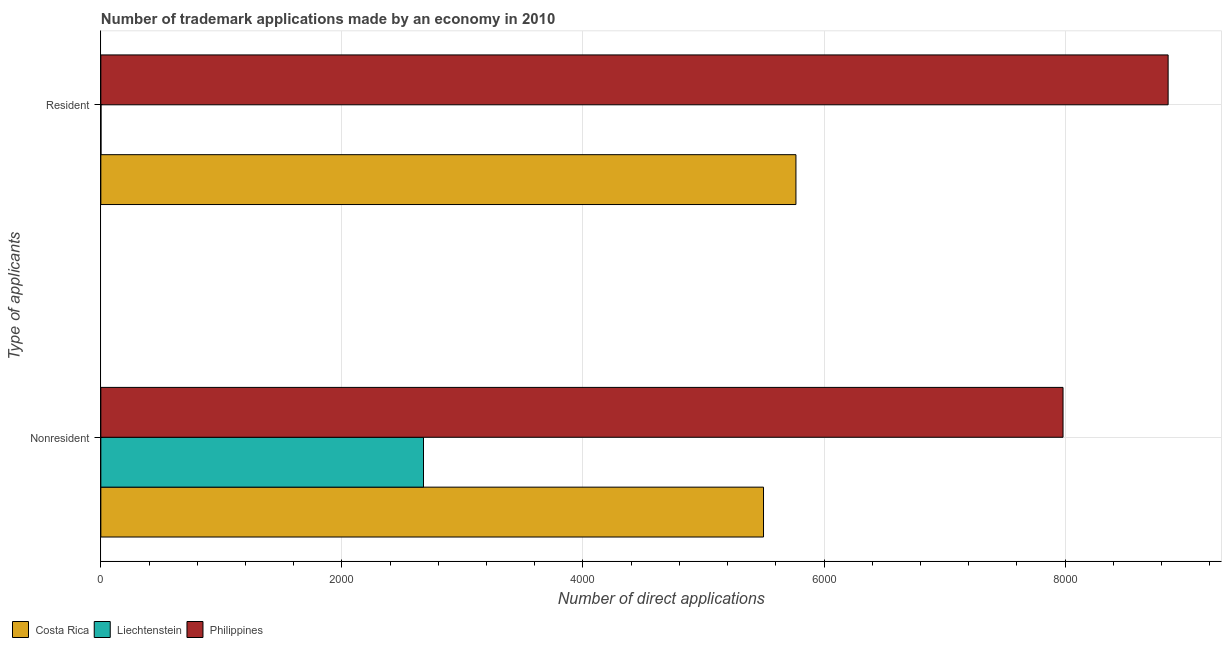How many different coloured bars are there?
Make the answer very short. 3. How many bars are there on the 2nd tick from the top?
Offer a very short reply. 3. What is the label of the 1st group of bars from the top?
Give a very brief answer. Resident. What is the number of trademark applications made by residents in Liechtenstein?
Your answer should be compact. 1. Across all countries, what is the maximum number of trademark applications made by residents?
Provide a succinct answer. 8855. Across all countries, what is the minimum number of trademark applications made by non residents?
Offer a terse response. 2677. In which country was the number of trademark applications made by non residents minimum?
Your answer should be very brief. Liechtenstein. What is the total number of trademark applications made by non residents in the graph?
Offer a terse response. 1.62e+04. What is the difference between the number of trademark applications made by non residents in Philippines and that in Costa Rica?
Your response must be concise. 2485. What is the difference between the number of trademark applications made by residents in Philippines and the number of trademark applications made by non residents in Liechtenstein?
Provide a short and direct response. 6178. What is the average number of trademark applications made by residents per country?
Your answer should be very brief. 4874.33. What is the difference between the number of trademark applications made by non residents and number of trademark applications made by residents in Costa Rica?
Your response must be concise. -269. What is the ratio of the number of trademark applications made by residents in Philippines to that in Costa Rica?
Offer a very short reply. 1.54. Is the number of trademark applications made by non residents in Costa Rica less than that in Philippines?
Keep it short and to the point. Yes. What does the 3rd bar from the bottom in Resident represents?
Your answer should be compact. Philippines. How many countries are there in the graph?
Give a very brief answer. 3. What is the difference between two consecutive major ticks on the X-axis?
Ensure brevity in your answer.  2000. Are the values on the major ticks of X-axis written in scientific E-notation?
Provide a short and direct response. No. Does the graph contain any zero values?
Offer a terse response. No. Does the graph contain grids?
Your answer should be compact. Yes. Where does the legend appear in the graph?
Offer a terse response. Bottom left. How are the legend labels stacked?
Offer a very short reply. Horizontal. What is the title of the graph?
Give a very brief answer. Number of trademark applications made by an economy in 2010. Does "Low & middle income" appear as one of the legend labels in the graph?
Your response must be concise. No. What is the label or title of the X-axis?
Give a very brief answer. Number of direct applications. What is the label or title of the Y-axis?
Give a very brief answer. Type of applicants. What is the Number of direct applications in Costa Rica in Nonresident?
Provide a short and direct response. 5498. What is the Number of direct applications in Liechtenstein in Nonresident?
Keep it short and to the point. 2677. What is the Number of direct applications of Philippines in Nonresident?
Keep it short and to the point. 7983. What is the Number of direct applications of Costa Rica in Resident?
Provide a succinct answer. 5767. What is the Number of direct applications in Philippines in Resident?
Keep it short and to the point. 8855. Across all Type of applicants, what is the maximum Number of direct applications of Costa Rica?
Offer a terse response. 5767. Across all Type of applicants, what is the maximum Number of direct applications in Liechtenstein?
Give a very brief answer. 2677. Across all Type of applicants, what is the maximum Number of direct applications in Philippines?
Your response must be concise. 8855. Across all Type of applicants, what is the minimum Number of direct applications in Costa Rica?
Provide a succinct answer. 5498. Across all Type of applicants, what is the minimum Number of direct applications of Philippines?
Give a very brief answer. 7983. What is the total Number of direct applications of Costa Rica in the graph?
Ensure brevity in your answer.  1.13e+04. What is the total Number of direct applications in Liechtenstein in the graph?
Ensure brevity in your answer.  2678. What is the total Number of direct applications of Philippines in the graph?
Your answer should be compact. 1.68e+04. What is the difference between the Number of direct applications of Costa Rica in Nonresident and that in Resident?
Provide a short and direct response. -269. What is the difference between the Number of direct applications in Liechtenstein in Nonresident and that in Resident?
Give a very brief answer. 2676. What is the difference between the Number of direct applications of Philippines in Nonresident and that in Resident?
Make the answer very short. -872. What is the difference between the Number of direct applications of Costa Rica in Nonresident and the Number of direct applications of Liechtenstein in Resident?
Your answer should be compact. 5497. What is the difference between the Number of direct applications of Costa Rica in Nonresident and the Number of direct applications of Philippines in Resident?
Your response must be concise. -3357. What is the difference between the Number of direct applications in Liechtenstein in Nonresident and the Number of direct applications in Philippines in Resident?
Your answer should be compact. -6178. What is the average Number of direct applications of Costa Rica per Type of applicants?
Offer a terse response. 5632.5. What is the average Number of direct applications of Liechtenstein per Type of applicants?
Make the answer very short. 1339. What is the average Number of direct applications in Philippines per Type of applicants?
Offer a terse response. 8419. What is the difference between the Number of direct applications in Costa Rica and Number of direct applications in Liechtenstein in Nonresident?
Keep it short and to the point. 2821. What is the difference between the Number of direct applications of Costa Rica and Number of direct applications of Philippines in Nonresident?
Provide a short and direct response. -2485. What is the difference between the Number of direct applications of Liechtenstein and Number of direct applications of Philippines in Nonresident?
Provide a short and direct response. -5306. What is the difference between the Number of direct applications of Costa Rica and Number of direct applications of Liechtenstein in Resident?
Your response must be concise. 5766. What is the difference between the Number of direct applications of Costa Rica and Number of direct applications of Philippines in Resident?
Provide a succinct answer. -3088. What is the difference between the Number of direct applications in Liechtenstein and Number of direct applications in Philippines in Resident?
Offer a very short reply. -8854. What is the ratio of the Number of direct applications of Costa Rica in Nonresident to that in Resident?
Your answer should be compact. 0.95. What is the ratio of the Number of direct applications of Liechtenstein in Nonresident to that in Resident?
Give a very brief answer. 2677. What is the ratio of the Number of direct applications of Philippines in Nonresident to that in Resident?
Your answer should be very brief. 0.9. What is the difference between the highest and the second highest Number of direct applications of Costa Rica?
Offer a very short reply. 269. What is the difference between the highest and the second highest Number of direct applications in Liechtenstein?
Provide a succinct answer. 2676. What is the difference between the highest and the second highest Number of direct applications in Philippines?
Keep it short and to the point. 872. What is the difference between the highest and the lowest Number of direct applications of Costa Rica?
Offer a terse response. 269. What is the difference between the highest and the lowest Number of direct applications in Liechtenstein?
Ensure brevity in your answer.  2676. What is the difference between the highest and the lowest Number of direct applications of Philippines?
Offer a terse response. 872. 